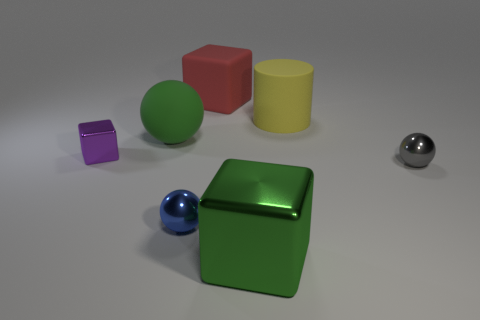The small thing that is left of the red matte object and to the right of the purple block is what color?
Give a very brief answer. Blue. There is a green metallic thing; what number of large green blocks are right of it?
Provide a succinct answer. 0. What number of things are either rubber things or large rubber things that are on the left side of the big red object?
Offer a terse response. 3. There is a red block behind the purple thing; are there any large metal blocks left of it?
Your answer should be very brief. No. There is a metallic cube that is on the left side of the matte sphere; what is its color?
Provide a succinct answer. Purple. Is the number of blue metallic spheres on the right side of the red thing the same as the number of green cylinders?
Provide a succinct answer. Yes. There is a tiny object that is to the left of the tiny gray ball and in front of the purple cube; what shape is it?
Provide a short and direct response. Sphere. There is another metallic thing that is the same shape as the small gray metallic object; what is its color?
Ensure brevity in your answer.  Blue. Is there anything else that is the same color as the large ball?
Give a very brief answer. Yes. What shape is the large green object that is on the left side of the big green object in front of the big green thing that is to the left of the big green metal block?
Offer a very short reply. Sphere. 